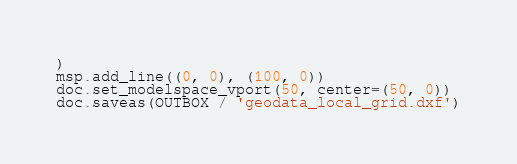<code> <loc_0><loc_0><loc_500><loc_500><_Python_>)
msp.add_line((0, 0), (100, 0))
doc.set_modelspace_vport(50, center=(50, 0))
doc.saveas(OUTBOX / 'geodata_local_grid.dxf')

</code> 